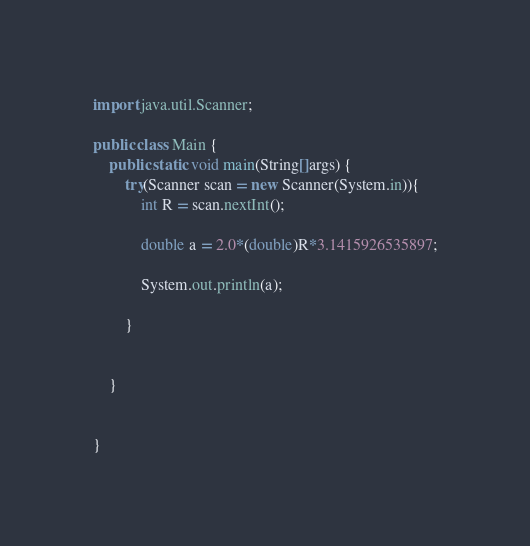<code> <loc_0><loc_0><loc_500><loc_500><_Java_>import java.util.Scanner;

public class Main {
	public static void main(String[]args) {
		try(Scanner scan = new Scanner(System.in)){
			int R = scan.nextInt();
			
			double a = 2.0*(double)R*3.1415926535897;
			
			System.out.println(a);
			
		}
		
		
	}
		

}
</code> 